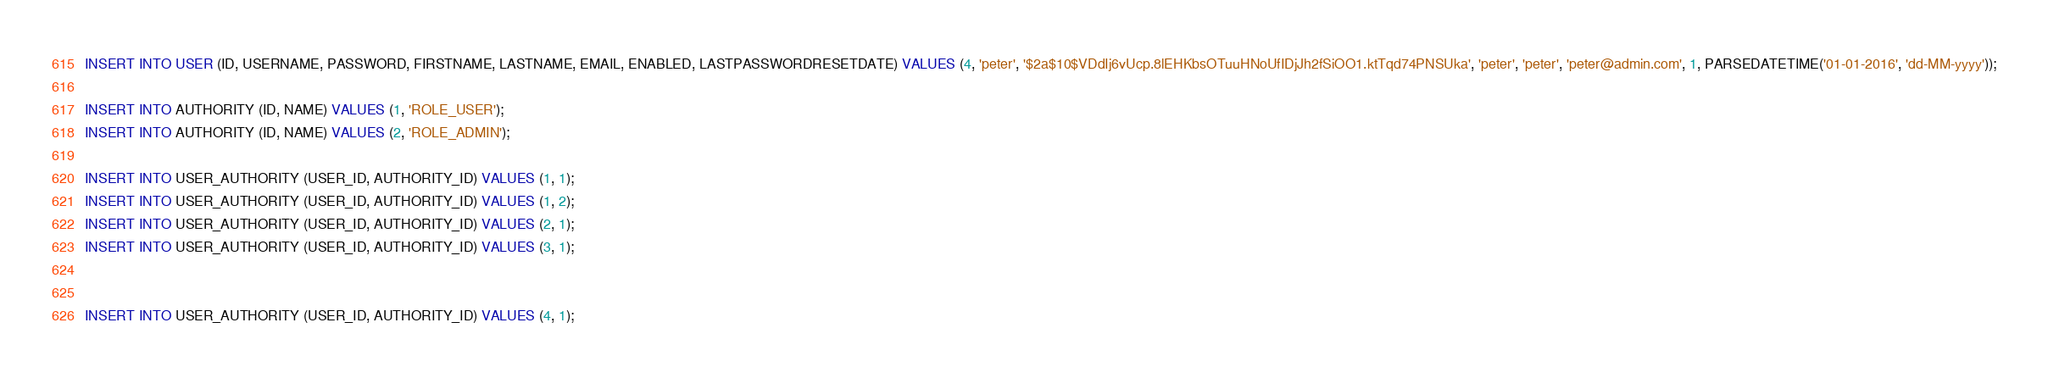<code> <loc_0><loc_0><loc_500><loc_500><_SQL_>INSERT INTO USER (ID, USERNAME, PASSWORD, FIRSTNAME, LASTNAME, EMAIL, ENABLED, LASTPASSWORDRESETDATE) VALUES (4, 'peter', '$2a$10$VDdIj6vUcp.8lEHKbsOTuuHNoUfIDjJh2fSiOO1.ktTqd74PNSUka', 'peter', 'peter', 'peter@admin.com', 1, PARSEDATETIME('01-01-2016', 'dd-MM-yyyy'));

INSERT INTO AUTHORITY (ID, NAME) VALUES (1, 'ROLE_USER');
INSERT INTO AUTHORITY (ID, NAME) VALUES (2, 'ROLE_ADMIN');

INSERT INTO USER_AUTHORITY (USER_ID, AUTHORITY_ID) VALUES (1, 1);
INSERT INTO USER_AUTHORITY (USER_ID, AUTHORITY_ID) VALUES (1, 2);
INSERT INTO USER_AUTHORITY (USER_ID, AUTHORITY_ID) VALUES (2, 1);
INSERT INTO USER_AUTHORITY (USER_ID, AUTHORITY_ID) VALUES (3, 1);


INSERT INTO USER_AUTHORITY (USER_ID, AUTHORITY_ID) VALUES (4, 1);
</code> 